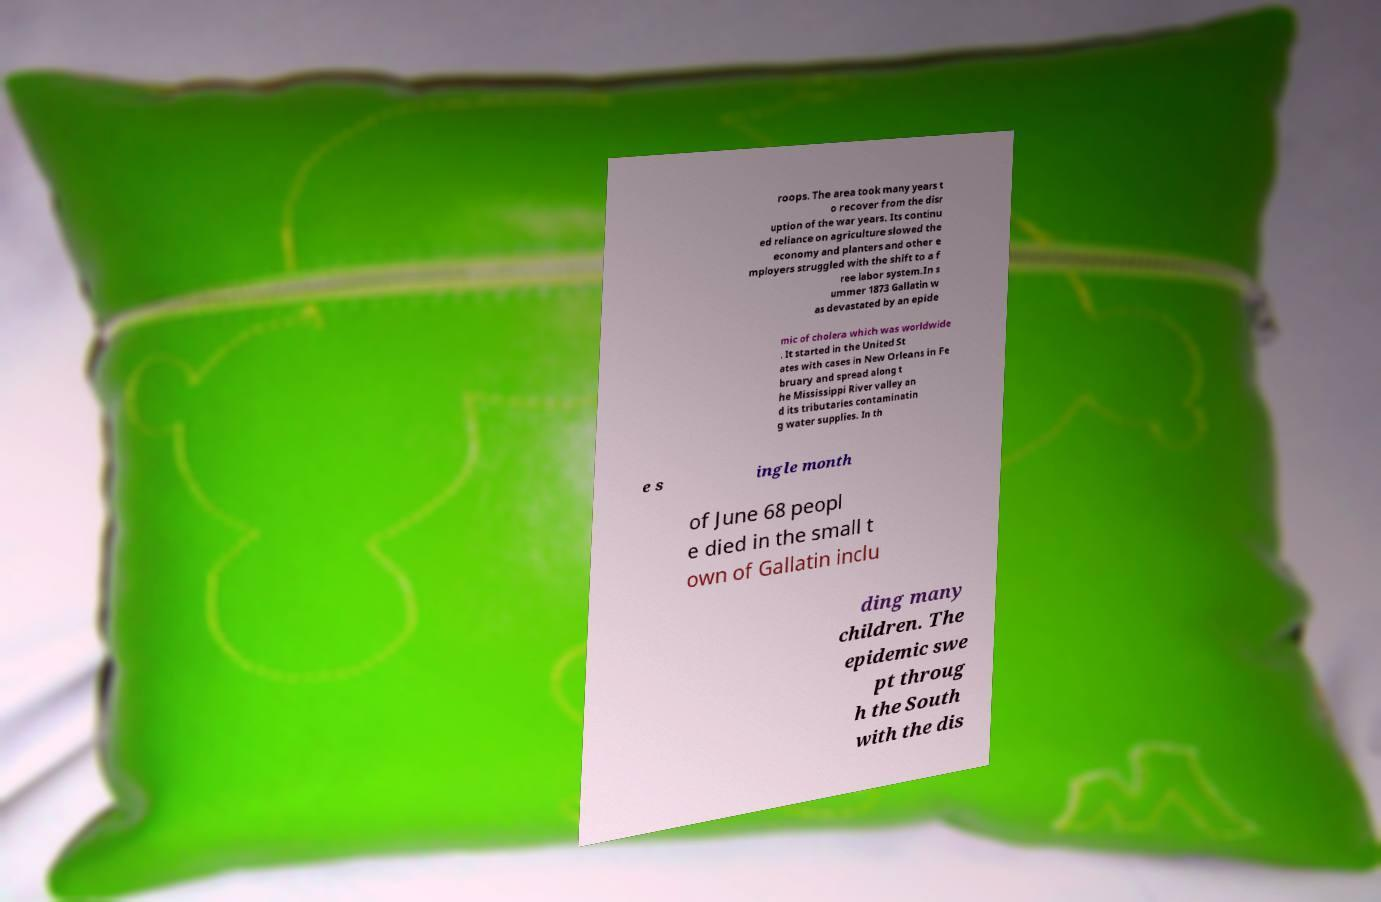Please read and relay the text visible in this image. What does it say? roops. The area took many years t o recover from the disr uption of the war years. Its continu ed reliance on agriculture slowed the economy and planters and other e mployers struggled with the shift to a f ree labor system.In s ummer 1873 Gallatin w as devastated by an epide mic of cholera which was worldwide . It started in the United St ates with cases in New Orleans in Fe bruary and spread along t he Mississippi River valley an d its tributaries contaminatin g water supplies. In th e s ingle month of June 68 peopl e died in the small t own of Gallatin inclu ding many children. The epidemic swe pt throug h the South with the dis 